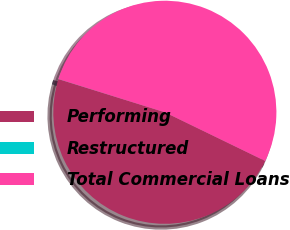Convert chart to OTSL. <chart><loc_0><loc_0><loc_500><loc_500><pie_chart><fcel>Performing<fcel>Restructured<fcel>Total Commercial Loans<nl><fcel>47.62%<fcel>0.01%<fcel>52.38%<nl></chart> 